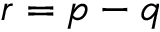<formula> <loc_0><loc_0><loc_500><loc_500>r = p - q</formula> 